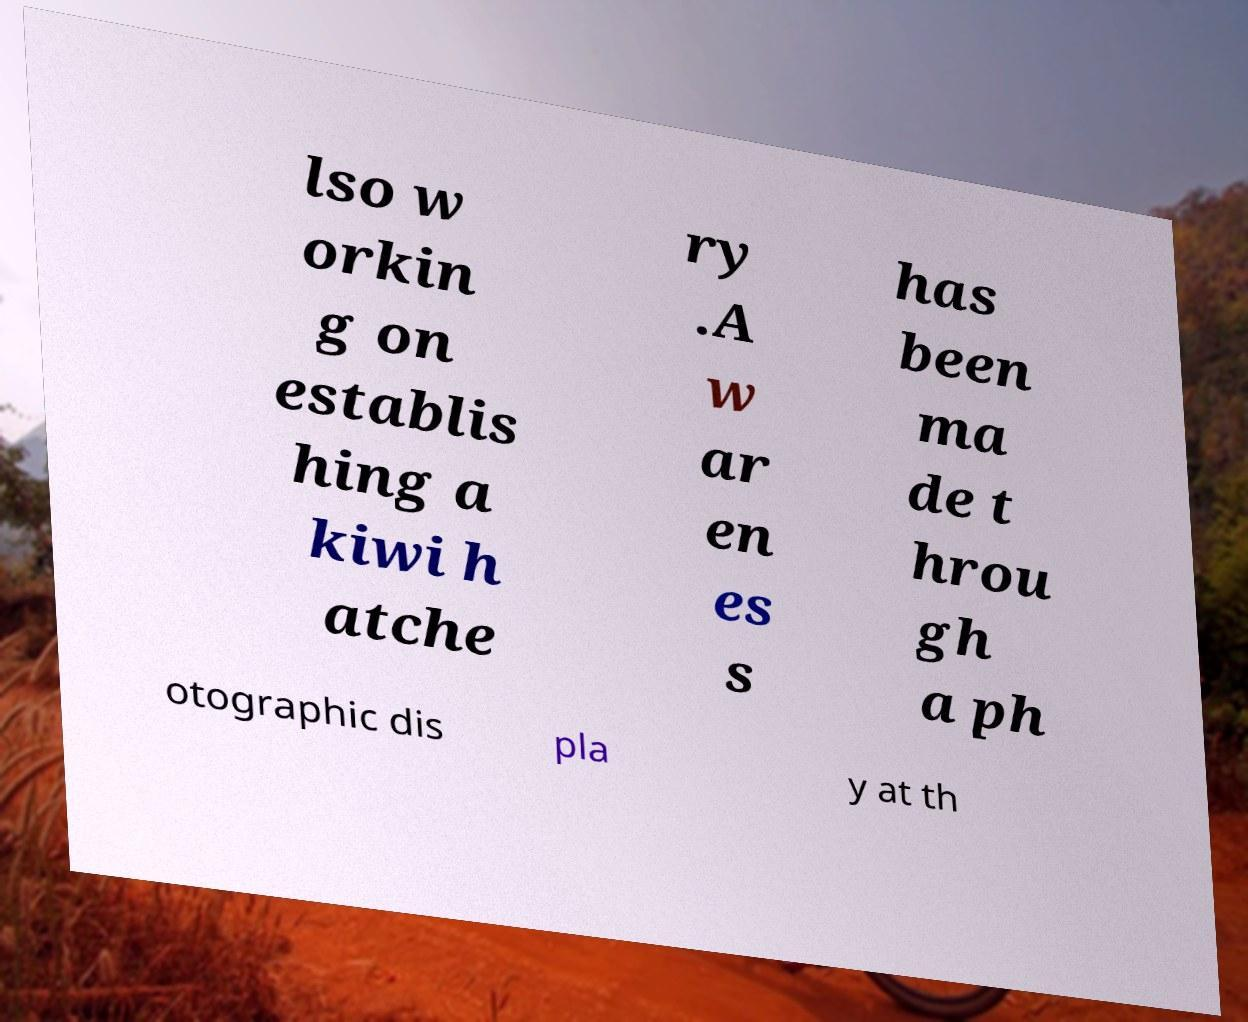There's text embedded in this image that I need extracted. Can you transcribe it verbatim? lso w orkin g on establis hing a kiwi h atche ry .A w ar en es s has been ma de t hrou gh a ph otographic dis pla y at th 